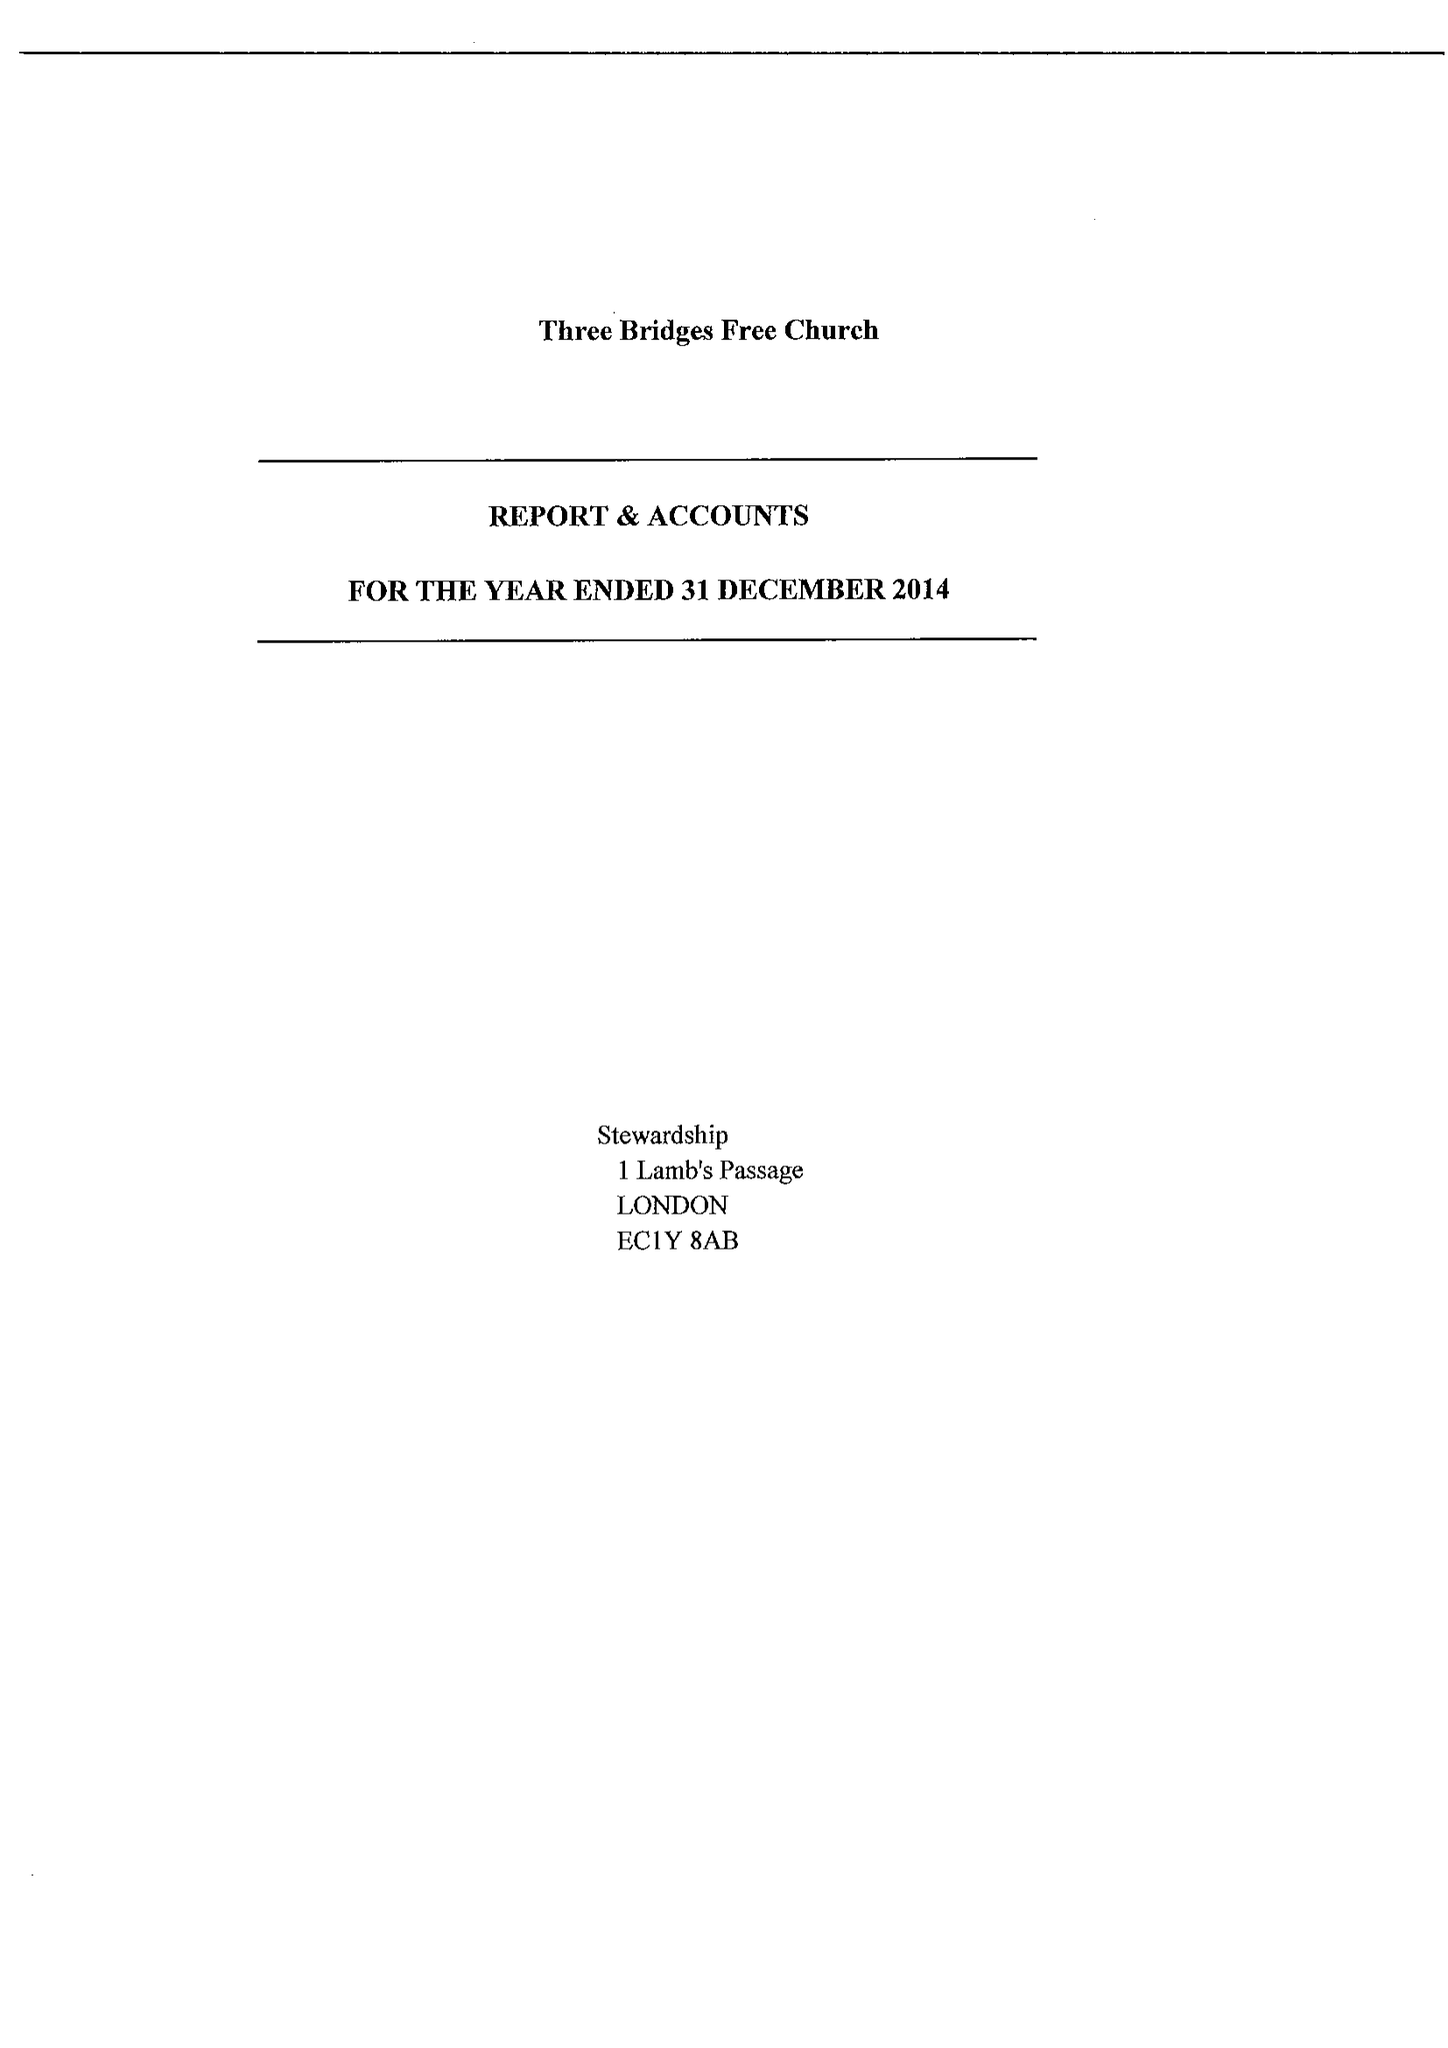What is the value for the report_date?
Answer the question using a single word or phrase. 2014-12-31 